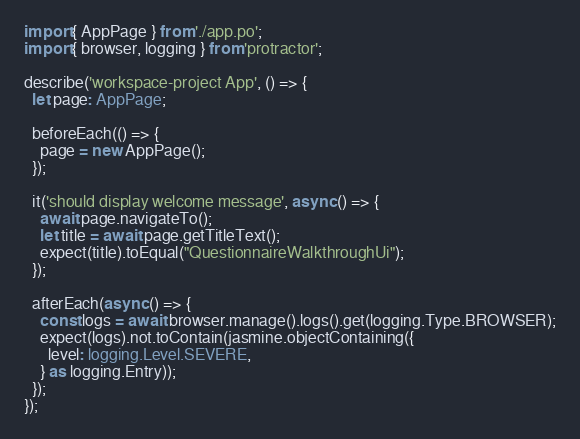<code> <loc_0><loc_0><loc_500><loc_500><_TypeScript_>import { AppPage } from './app.po';
import { browser, logging } from 'protractor';

describe('workspace-project App', () => {
  let page: AppPage;

  beforeEach(() => {
    page = new AppPage();
  });

  it('should display welcome message', async () => {
    await page.navigateTo();
    let title = await page.getTitleText();
    expect(title).toEqual("QuestionnaireWalkthroughUi");
  });

  afterEach(async () => {
    const logs = await browser.manage().logs().get(logging.Type.BROWSER);
    expect(logs).not.toContain(jasmine.objectContaining({
      level: logging.Level.SEVERE,
    } as logging.Entry));
  });
});
</code> 